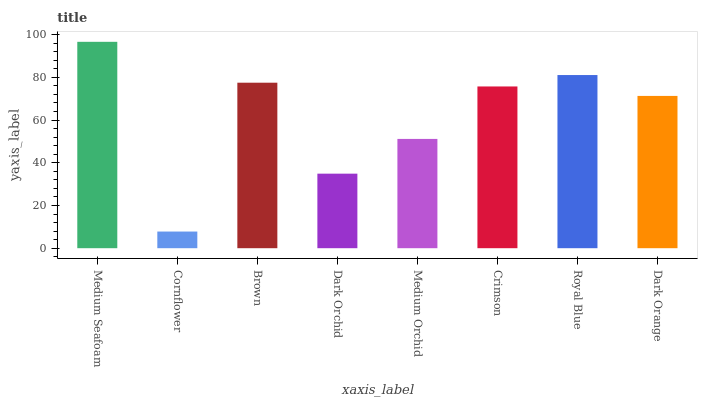Is Cornflower the minimum?
Answer yes or no. Yes. Is Medium Seafoam the maximum?
Answer yes or no. Yes. Is Brown the minimum?
Answer yes or no. No. Is Brown the maximum?
Answer yes or no. No. Is Brown greater than Cornflower?
Answer yes or no. Yes. Is Cornflower less than Brown?
Answer yes or no. Yes. Is Cornflower greater than Brown?
Answer yes or no. No. Is Brown less than Cornflower?
Answer yes or no. No. Is Crimson the high median?
Answer yes or no. Yes. Is Dark Orange the low median?
Answer yes or no. Yes. Is Medium Orchid the high median?
Answer yes or no. No. Is Medium Seafoam the low median?
Answer yes or no. No. 